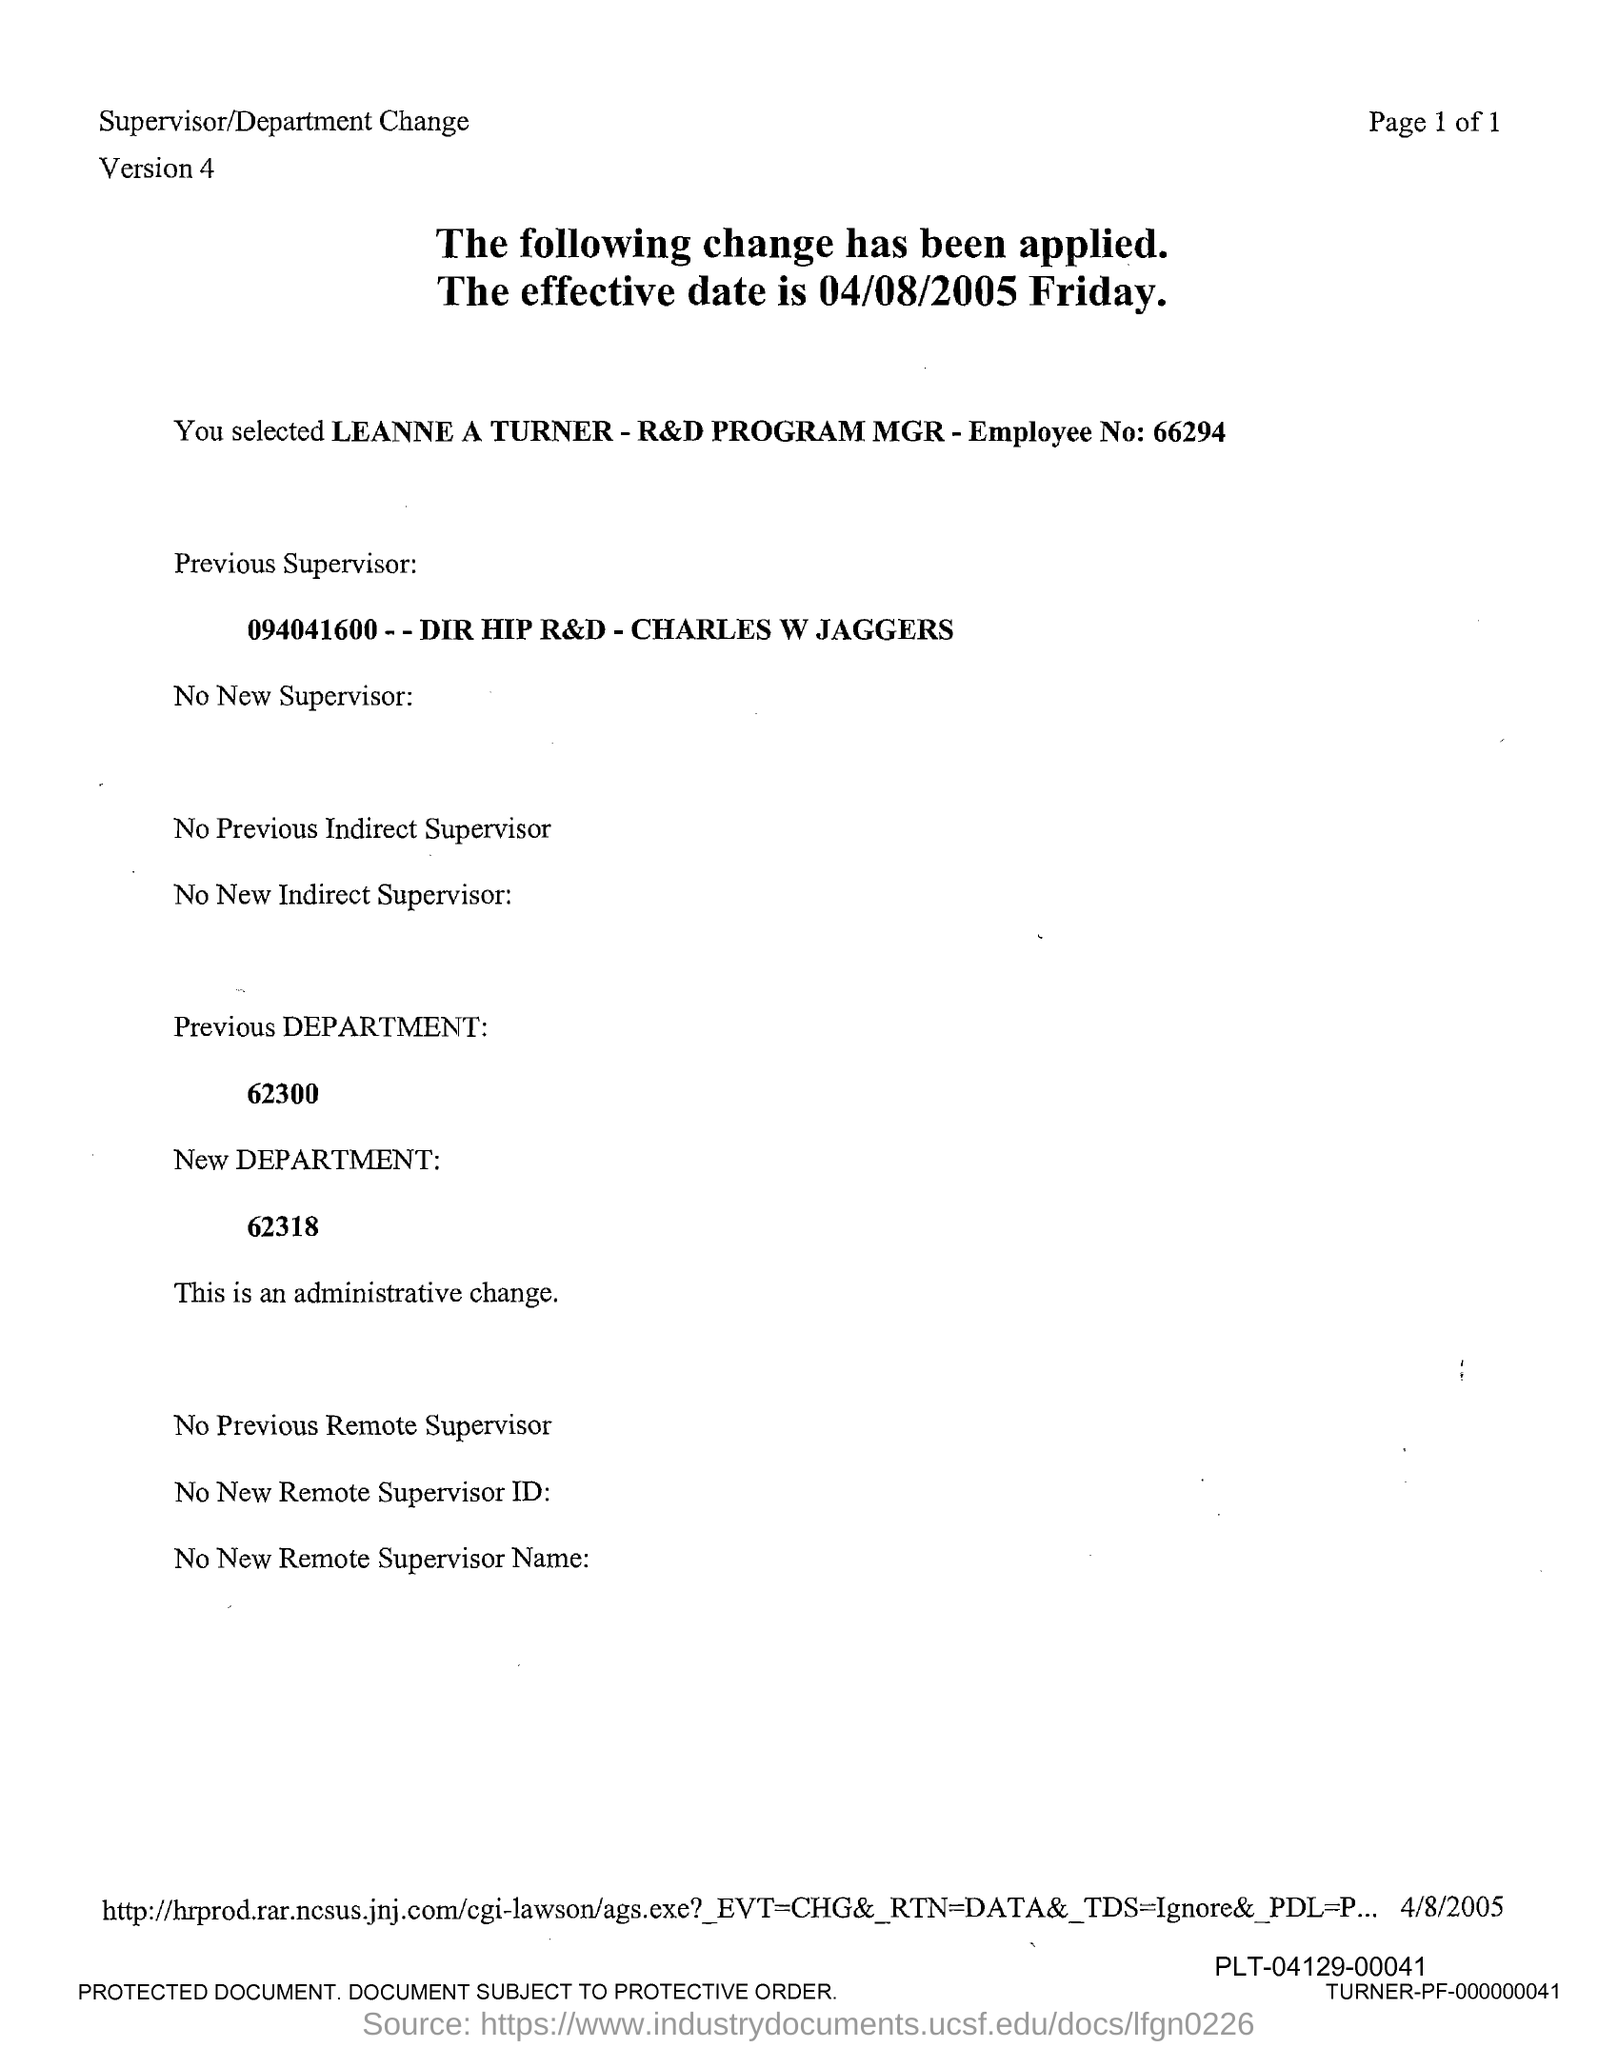What is the employee no?
Your response must be concise. 66294. What is the new department number?
Give a very brief answer. 62318. What is the previous department number?
Provide a short and direct response. 62300. What is the version mentioned in the document?
Make the answer very short. 4. 